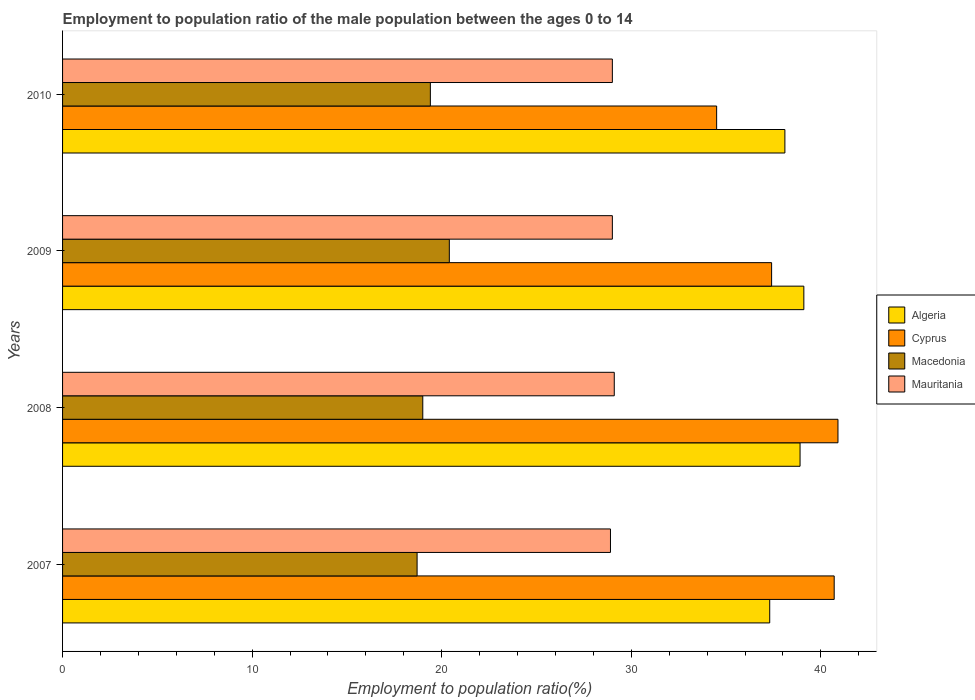How many different coloured bars are there?
Your answer should be compact. 4. How many groups of bars are there?
Your answer should be very brief. 4. Are the number of bars on each tick of the Y-axis equal?
Provide a succinct answer. Yes. How many bars are there on the 2nd tick from the bottom?
Provide a succinct answer. 4. What is the label of the 3rd group of bars from the top?
Offer a very short reply. 2008. What is the employment to population ratio in Mauritania in 2008?
Make the answer very short. 29.1. Across all years, what is the maximum employment to population ratio in Cyprus?
Offer a very short reply. 40.9. Across all years, what is the minimum employment to population ratio in Mauritania?
Your answer should be compact. 28.9. What is the total employment to population ratio in Cyprus in the graph?
Ensure brevity in your answer.  153.5. What is the difference between the employment to population ratio in Macedonia in 2008 and the employment to population ratio in Mauritania in 2007?
Provide a short and direct response. -9.9. In the year 2007, what is the difference between the employment to population ratio in Cyprus and employment to population ratio in Mauritania?
Your answer should be very brief. 11.8. What is the ratio of the employment to population ratio in Algeria in 2007 to that in 2009?
Offer a terse response. 0.95. Is the difference between the employment to population ratio in Cyprus in 2007 and 2008 greater than the difference between the employment to population ratio in Mauritania in 2007 and 2008?
Provide a short and direct response. No. What is the difference between the highest and the second highest employment to population ratio in Mauritania?
Offer a terse response. 0.1. What is the difference between the highest and the lowest employment to population ratio in Mauritania?
Make the answer very short. 0.2. Is it the case that in every year, the sum of the employment to population ratio in Macedonia and employment to population ratio in Algeria is greater than the sum of employment to population ratio in Mauritania and employment to population ratio in Cyprus?
Offer a terse response. No. What does the 1st bar from the top in 2007 represents?
Ensure brevity in your answer.  Mauritania. What does the 3rd bar from the bottom in 2009 represents?
Your response must be concise. Macedonia. How many bars are there?
Make the answer very short. 16. Are all the bars in the graph horizontal?
Give a very brief answer. Yes. How many years are there in the graph?
Make the answer very short. 4. Does the graph contain any zero values?
Ensure brevity in your answer.  No. Where does the legend appear in the graph?
Ensure brevity in your answer.  Center right. How many legend labels are there?
Your response must be concise. 4. What is the title of the graph?
Your answer should be compact. Employment to population ratio of the male population between the ages 0 to 14. Does "Channel Islands" appear as one of the legend labels in the graph?
Offer a very short reply. No. What is the label or title of the X-axis?
Give a very brief answer. Employment to population ratio(%). What is the Employment to population ratio(%) of Algeria in 2007?
Provide a succinct answer. 37.3. What is the Employment to population ratio(%) in Cyprus in 2007?
Keep it short and to the point. 40.7. What is the Employment to population ratio(%) in Macedonia in 2007?
Make the answer very short. 18.7. What is the Employment to population ratio(%) in Mauritania in 2007?
Provide a short and direct response. 28.9. What is the Employment to population ratio(%) in Algeria in 2008?
Ensure brevity in your answer.  38.9. What is the Employment to population ratio(%) in Cyprus in 2008?
Make the answer very short. 40.9. What is the Employment to population ratio(%) of Mauritania in 2008?
Your answer should be compact. 29.1. What is the Employment to population ratio(%) in Algeria in 2009?
Your answer should be very brief. 39.1. What is the Employment to population ratio(%) of Cyprus in 2009?
Give a very brief answer. 37.4. What is the Employment to population ratio(%) of Macedonia in 2009?
Give a very brief answer. 20.4. What is the Employment to population ratio(%) in Algeria in 2010?
Your answer should be very brief. 38.1. What is the Employment to population ratio(%) in Cyprus in 2010?
Your answer should be very brief. 34.5. What is the Employment to population ratio(%) of Macedonia in 2010?
Offer a terse response. 19.4. What is the Employment to population ratio(%) of Mauritania in 2010?
Make the answer very short. 29. Across all years, what is the maximum Employment to population ratio(%) in Algeria?
Provide a succinct answer. 39.1. Across all years, what is the maximum Employment to population ratio(%) of Cyprus?
Keep it short and to the point. 40.9. Across all years, what is the maximum Employment to population ratio(%) in Macedonia?
Give a very brief answer. 20.4. Across all years, what is the maximum Employment to population ratio(%) in Mauritania?
Your answer should be very brief. 29.1. Across all years, what is the minimum Employment to population ratio(%) of Algeria?
Your answer should be compact. 37.3. Across all years, what is the minimum Employment to population ratio(%) of Cyprus?
Offer a very short reply. 34.5. Across all years, what is the minimum Employment to population ratio(%) in Macedonia?
Your answer should be compact. 18.7. Across all years, what is the minimum Employment to population ratio(%) in Mauritania?
Offer a terse response. 28.9. What is the total Employment to population ratio(%) in Algeria in the graph?
Offer a terse response. 153.4. What is the total Employment to population ratio(%) in Cyprus in the graph?
Offer a terse response. 153.5. What is the total Employment to population ratio(%) in Macedonia in the graph?
Your answer should be very brief. 77.5. What is the total Employment to population ratio(%) of Mauritania in the graph?
Your answer should be very brief. 116. What is the difference between the Employment to population ratio(%) of Algeria in 2007 and that in 2008?
Offer a very short reply. -1.6. What is the difference between the Employment to population ratio(%) of Cyprus in 2007 and that in 2008?
Provide a succinct answer. -0.2. What is the difference between the Employment to population ratio(%) in Macedonia in 2007 and that in 2008?
Your response must be concise. -0.3. What is the difference between the Employment to population ratio(%) in Algeria in 2008 and that in 2009?
Your answer should be very brief. -0.2. What is the difference between the Employment to population ratio(%) of Cyprus in 2008 and that in 2009?
Offer a terse response. 3.5. What is the difference between the Employment to population ratio(%) of Mauritania in 2008 and that in 2009?
Provide a short and direct response. 0.1. What is the difference between the Employment to population ratio(%) of Algeria in 2008 and that in 2010?
Your answer should be very brief. 0.8. What is the difference between the Employment to population ratio(%) of Macedonia in 2008 and that in 2010?
Ensure brevity in your answer.  -0.4. What is the difference between the Employment to population ratio(%) in Mauritania in 2008 and that in 2010?
Keep it short and to the point. 0.1. What is the difference between the Employment to population ratio(%) in Algeria in 2009 and that in 2010?
Provide a succinct answer. 1. What is the difference between the Employment to population ratio(%) in Mauritania in 2009 and that in 2010?
Make the answer very short. 0. What is the difference between the Employment to population ratio(%) in Algeria in 2007 and the Employment to population ratio(%) in Cyprus in 2008?
Make the answer very short. -3.6. What is the difference between the Employment to population ratio(%) of Algeria in 2007 and the Employment to population ratio(%) of Macedonia in 2008?
Make the answer very short. 18.3. What is the difference between the Employment to population ratio(%) of Algeria in 2007 and the Employment to population ratio(%) of Mauritania in 2008?
Give a very brief answer. 8.2. What is the difference between the Employment to population ratio(%) of Cyprus in 2007 and the Employment to population ratio(%) of Macedonia in 2008?
Ensure brevity in your answer.  21.7. What is the difference between the Employment to population ratio(%) in Cyprus in 2007 and the Employment to population ratio(%) in Mauritania in 2008?
Keep it short and to the point. 11.6. What is the difference between the Employment to population ratio(%) of Algeria in 2007 and the Employment to population ratio(%) of Cyprus in 2009?
Provide a succinct answer. -0.1. What is the difference between the Employment to population ratio(%) in Algeria in 2007 and the Employment to population ratio(%) in Macedonia in 2009?
Your answer should be compact. 16.9. What is the difference between the Employment to population ratio(%) in Cyprus in 2007 and the Employment to population ratio(%) in Macedonia in 2009?
Give a very brief answer. 20.3. What is the difference between the Employment to population ratio(%) in Macedonia in 2007 and the Employment to population ratio(%) in Mauritania in 2009?
Provide a short and direct response. -10.3. What is the difference between the Employment to population ratio(%) in Algeria in 2007 and the Employment to population ratio(%) in Cyprus in 2010?
Provide a succinct answer. 2.8. What is the difference between the Employment to population ratio(%) in Algeria in 2007 and the Employment to population ratio(%) in Macedonia in 2010?
Provide a succinct answer. 17.9. What is the difference between the Employment to population ratio(%) in Cyprus in 2007 and the Employment to population ratio(%) in Macedonia in 2010?
Keep it short and to the point. 21.3. What is the difference between the Employment to population ratio(%) of Cyprus in 2008 and the Employment to population ratio(%) of Macedonia in 2009?
Your answer should be compact. 20.5. What is the difference between the Employment to population ratio(%) of Cyprus in 2008 and the Employment to population ratio(%) of Mauritania in 2009?
Your answer should be compact. 11.9. What is the difference between the Employment to population ratio(%) of Macedonia in 2008 and the Employment to population ratio(%) of Mauritania in 2009?
Provide a succinct answer. -10. What is the difference between the Employment to population ratio(%) of Cyprus in 2008 and the Employment to population ratio(%) of Macedonia in 2010?
Your answer should be compact. 21.5. What is the difference between the Employment to population ratio(%) of Cyprus in 2008 and the Employment to population ratio(%) of Mauritania in 2010?
Provide a short and direct response. 11.9. What is the difference between the Employment to population ratio(%) of Macedonia in 2008 and the Employment to population ratio(%) of Mauritania in 2010?
Ensure brevity in your answer.  -10. What is the difference between the Employment to population ratio(%) in Algeria in 2009 and the Employment to population ratio(%) in Cyprus in 2010?
Make the answer very short. 4.6. What is the difference between the Employment to population ratio(%) of Cyprus in 2009 and the Employment to population ratio(%) of Macedonia in 2010?
Keep it short and to the point. 18. What is the average Employment to population ratio(%) of Algeria per year?
Offer a terse response. 38.35. What is the average Employment to population ratio(%) of Cyprus per year?
Your answer should be compact. 38.38. What is the average Employment to population ratio(%) of Macedonia per year?
Your response must be concise. 19.38. What is the average Employment to population ratio(%) in Mauritania per year?
Your response must be concise. 29. In the year 2007, what is the difference between the Employment to population ratio(%) of Algeria and Employment to population ratio(%) of Cyprus?
Provide a short and direct response. -3.4. In the year 2007, what is the difference between the Employment to population ratio(%) in Algeria and Employment to population ratio(%) in Mauritania?
Offer a terse response. 8.4. In the year 2007, what is the difference between the Employment to population ratio(%) of Cyprus and Employment to population ratio(%) of Macedonia?
Provide a succinct answer. 22. In the year 2007, what is the difference between the Employment to population ratio(%) of Cyprus and Employment to population ratio(%) of Mauritania?
Offer a terse response. 11.8. In the year 2007, what is the difference between the Employment to population ratio(%) in Macedonia and Employment to population ratio(%) in Mauritania?
Give a very brief answer. -10.2. In the year 2008, what is the difference between the Employment to population ratio(%) in Algeria and Employment to population ratio(%) in Cyprus?
Your answer should be very brief. -2. In the year 2008, what is the difference between the Employment to population ratio(%) in Cyprus and Employment to population ratio(%) in Macedonia?
Offer a terse response. 21.9. In the year 2008, what is the difference between the Employment to population ratio(%) in Macedonia and Employment to population ratio(%) in Mauritania?
Your response must be concise. -10.1. In the year 2009, what is the difference between the Employment to population ratio(%) of Algeria and Employment to population ratio(%) of Macedonia?
Make the answer very short. 18.7. In the year 2009, what is the difference between the Employment to population ratio(%) in Algeria and Employment to population ratio(%) in Mauritania?
Provide a short and direct response. 10.1. In the year 2009, what is the difference between the Employment to population ratio(%) in Cyprus and Employment to population ratio(%) in Macedonia?
Your answer should be very brief. 17. In the year 2009, what is the difference between the Employment to population ratio(%) in Cyprus and Employment to population ratio(%) in Mauritania?
Your response must be concise. 8.4. In the year 2010, what is the difference between the Employment to population ratio(%) in Algeria and Employment to population ratio(%) in Mauritania?
Provide a short and direct response. 9.1. In the year 2010, what is the difference between the Employment to population ratio(%) in Cyprus and Employment to population ratio(%) in Macedonia?
Your answer should be compact. 15.1. In the year 2010, what is the difference between the Employment to population ratio(%) of Macedonia and Employment to population ratio(%) of Mauritania?
Make the answer very short. -9.6. What is the ratio of the Employment to population ratio(%) of Algeria in 2007 to that in 2008?
Your answer should be compact. 0.96. What is the ratio of the Employment to population ratio(%) in Macedonia in 2007 to that in 2008?
Your answer should be very brief. 0.98. What is the ratio of the Employment to population ratio(%) of Algeria in 2007 to that in 2009?
Your answer should be compact. 0.95. What is the ratio of the Employment to population ratio(%) in Cyprus in 2007 to that in 2009?
Your answer should be compact. 1.09. What is the ratio of the Employment to population ratio(%) in Mauritania in 2007 to that in 2009?
Provide a succinct answer. 1. What is the ratio of the Employment to population ratio(%) of Cyprus in 2007 to that in 2010?
Offer a terse response. 1.18. What is the ratio of the Employment to population ratio(%) of Macedonia in 2007 to that in 2010?
Offer a very short reply. 0.96. What is the ratio of the Employment to population ratio(%) in Mauritania in 2007 to that in 2010?
Your response must be concise. 1. What is the ratio of the Employment to population ratio(%) in Cyprus in 2008 to that in 2009?
Offer a very short reply. 1.09. What is the ratio of the Employment to population ratio(%) in Macedonia in 2008 to that in 2009?
Provide a short and direct response. 0.93. What is the ratio of the Employment to population ratio(%) of Mauritania in 2008 to that in 2009?
Your response must be concise. 1. What is the ratio of the Employment to population ratio(%) of Cyprus in 2008 to that in 2010?
Provide a succinct answer. 1.19. What is the ratio of the Employment to population ratio(%) of Macedonia in 2008 to that in 2010?
Make the answer very short. 0.98. What is the ratio of the Employment to population ratio(%) of Algeria in 2009 to that in 2010?
Provide a short and direct response. 1.03. What is the ratio of the Employment to population ratio(%) in Cyprus in 2009 to that in 2010?
Your response must be concise. 1.08. What is the ratio of the Employment to population ratio(%) in Macedonia in 2009 to that in 2010?
Your response must be concise. 1.05. What is the ratio of the Employment to population ratio(%) in Mauritania in 2009 to that in 2010?
Make the answer very short. 1. What is the difference between the highest and the second highest Employment to population ratio(%) in Algeria?
Your answer should be very brief. 0.2. What is the difference between the highest and the second highest Employment to population ratio(%) in Cyprus?
Offer a very short reply. 0.2. What is the difference between the highest and the lowest Employment to population ratio(%) in Macedonia?
Make the answer very short. 1.7. What is the difference between the highest and the lowest Employment to population ratio(%) of Mauritania?
Provide a succinct answer. 0.2. 